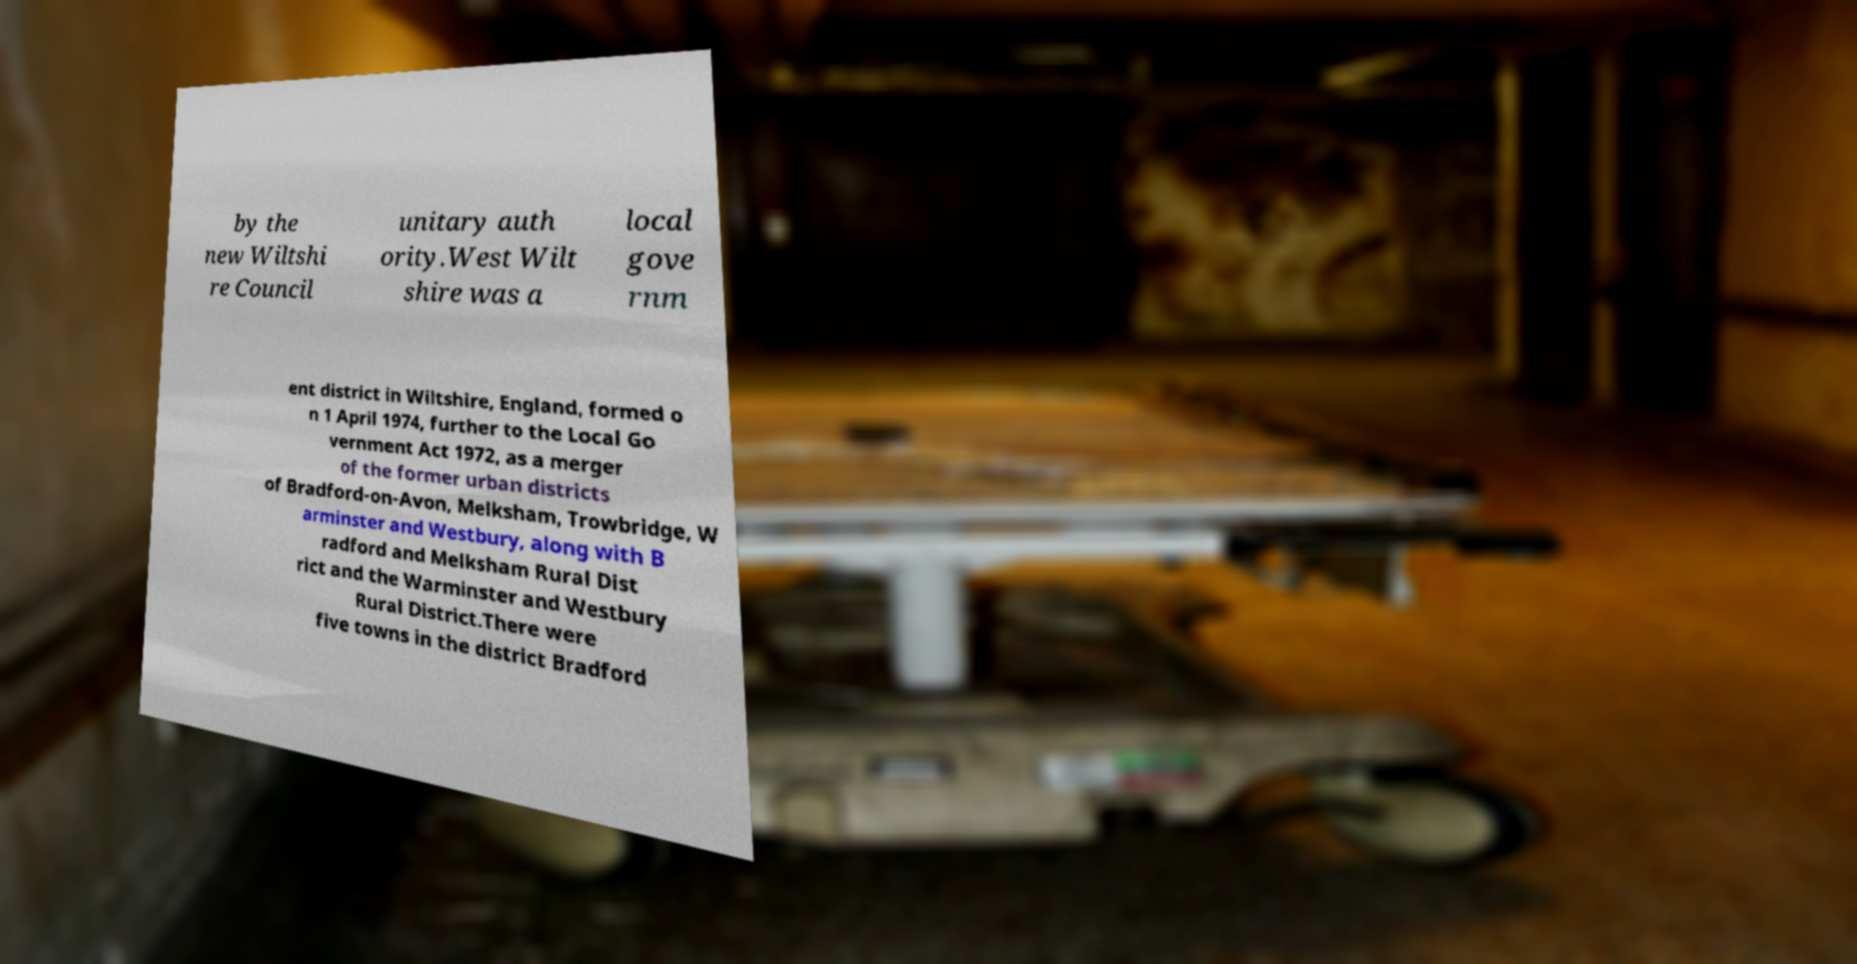What messages or text are displayed in this image? I need them in a readable, typed format. by the new Wiltshi re Council unitary auth ority.West Wilt shire was a local gove rnm ent district in Wiltshire, England, formed o n 1 April 1974, further to the Local Go vernment Act 1972, as a merger of the former urban districts of Bradford-on-Avon, Melksham, Trowbridge, W arminster and Westbury, along with B radford and Melksham Rural Dist rict and the Warminster and Westbury Rural District.There were five towns in the district Bradford 